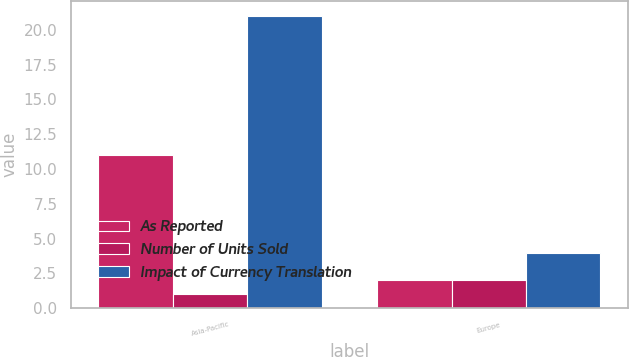Convert chart. <chart><loc_0><loc_0><loc_500><loc_500><stacked_bar_chart><ecel><fcel>Asia-Pacific<fcel>Europe<nl><fcel>As Reported<fcel>11<fcel>2<nl><fcel>Number of Units Sold<fcel>1<fcel>2<nl><fcel>Impact of Currency Translation<fcel>21<fcel>4<nl></chart> 